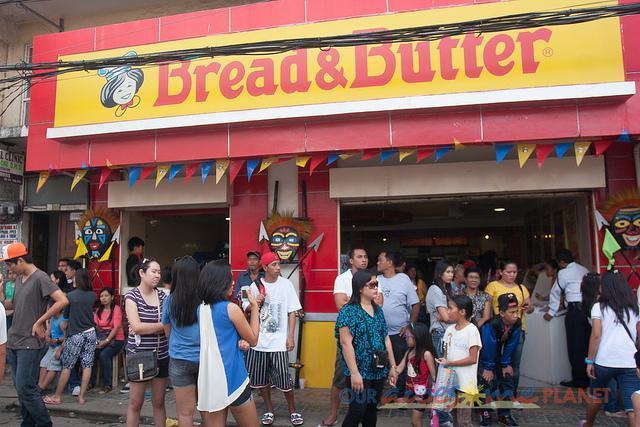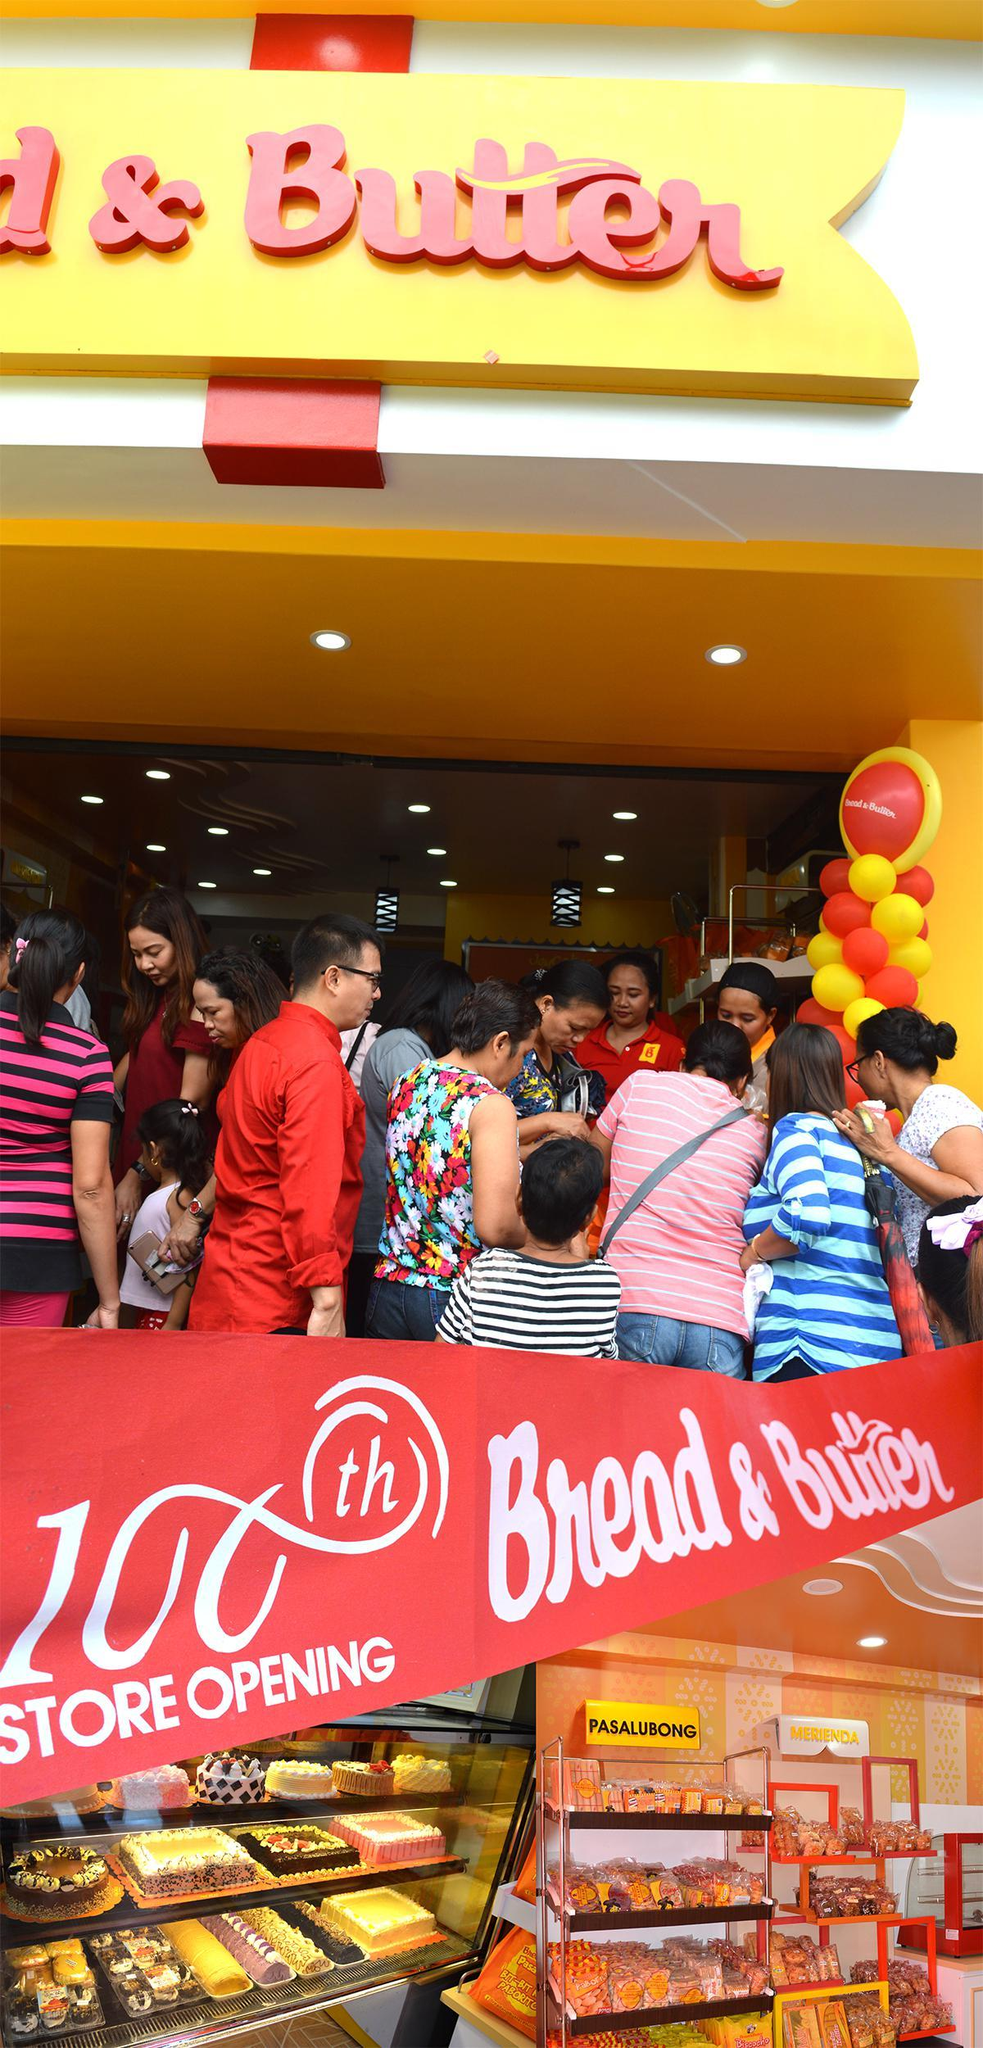The first image is the image on the left, the second image is the image on the right. Given the left and right images, does the statement "The right image shows an open-front shop with a yellow sign featuring a cartoon chef face on a red facade, and red and yellow balloons reaching as high as the doorway." hold true? Answer yes or no. No. 